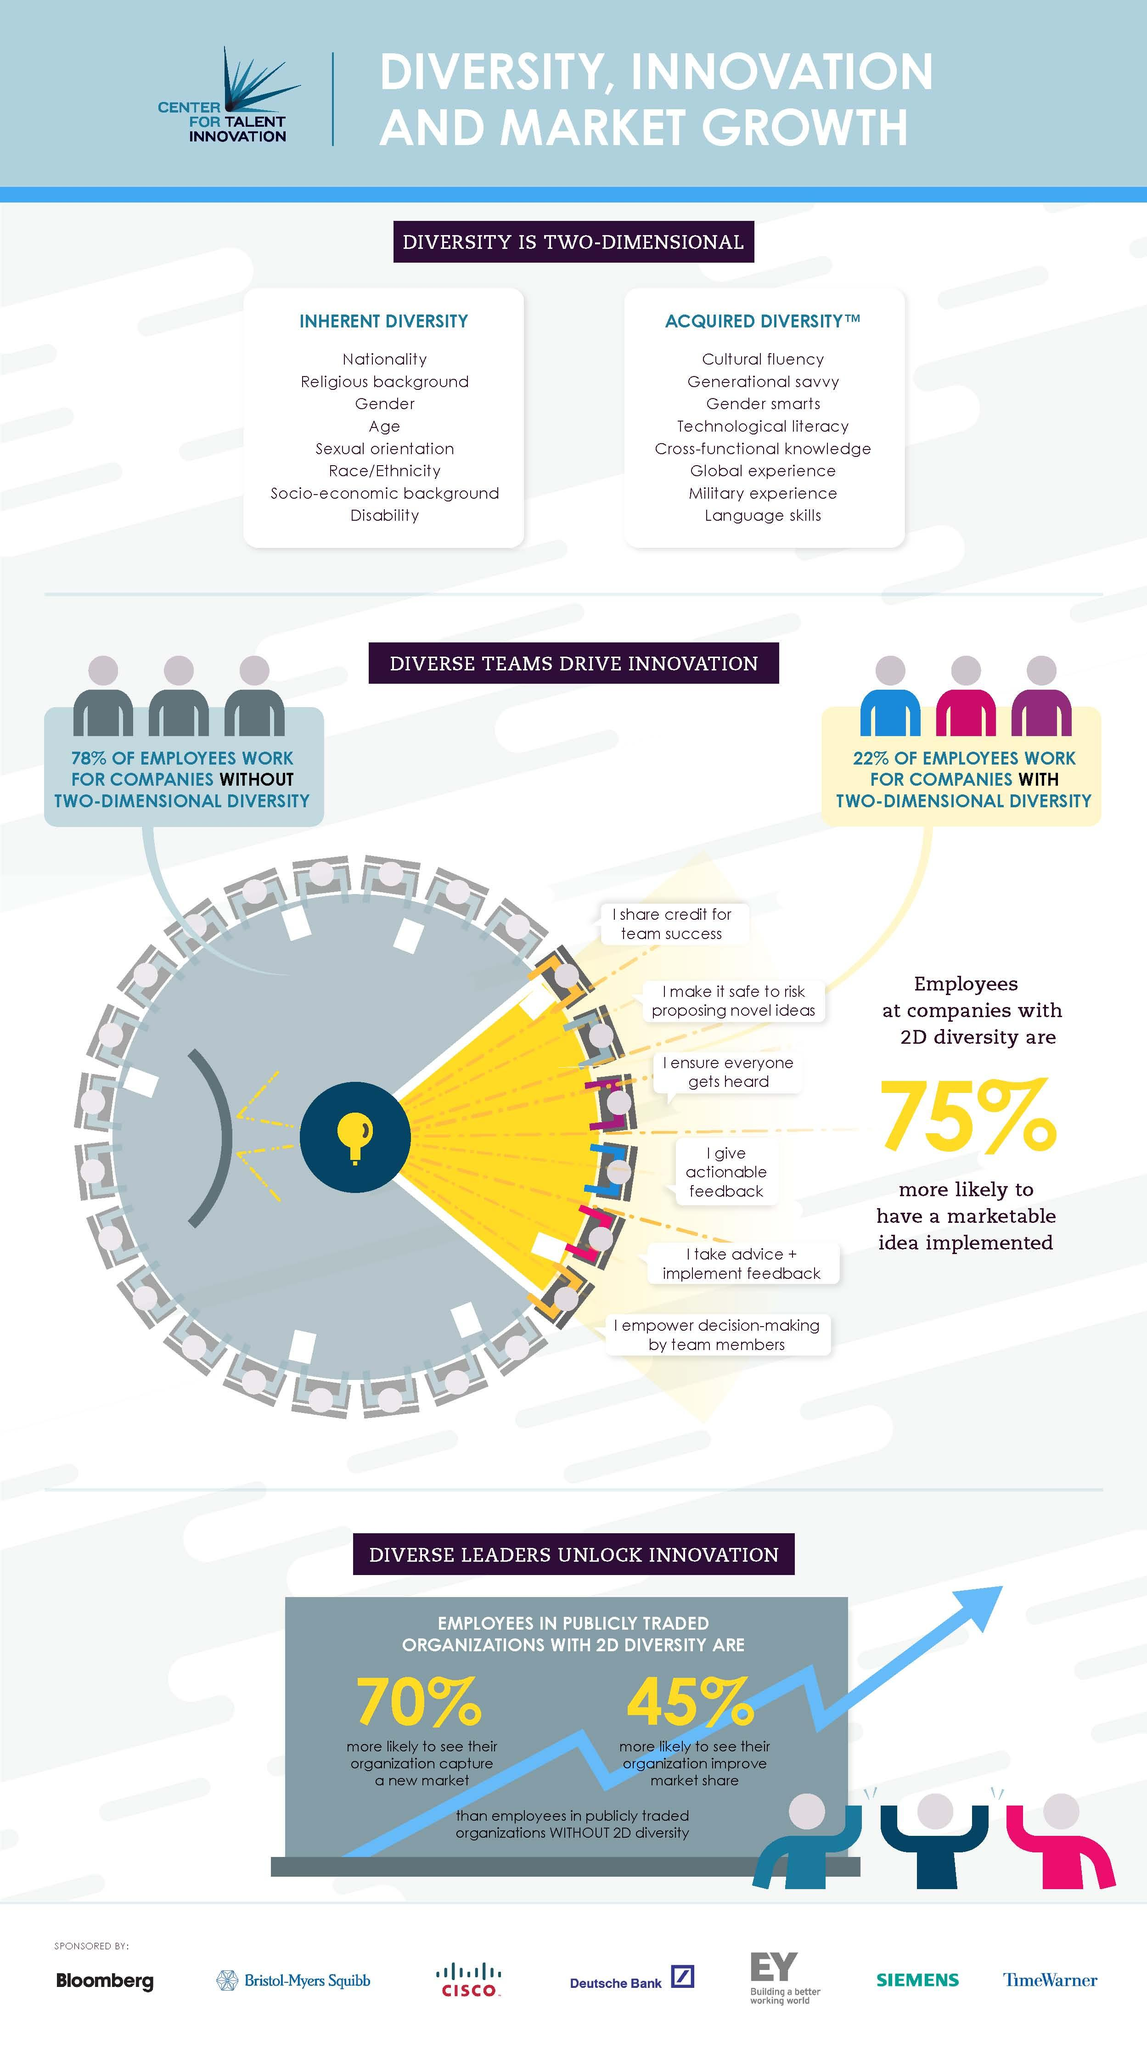List a handful of essential elements in this visual. The acquired diversity section includes global experience, military experience, and language skills, which are the last three items listed under this heading. The three top items given under the heading of inherent diversity are nationality, religious background, and gender. The infographic presents two dimensions of diversity, inherent diversity and acquired diversity. Employees at companies with increased diversity, particularly in terms of demographic diversity, are more likely to have their marketable ideas implemented. The question of whether a company with 2D diversity or a company without 2D diversity is more innovative is still a topic of debate. However, it is widely believed that companies with a diverse workforce tend to be more innovative as they bring together individuals with different backgrounds, experiences, and perspectives, which can lead to the generation of new and creative ideas. 